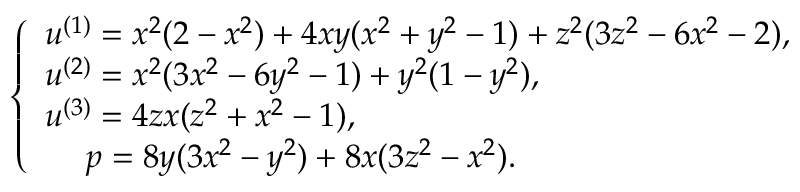Convert formula to latex. <formula><loc_0><loc_0><loc_500><loc_500>\left \{ \begin{array} { l l } { u ^ { ( 1 ) } = x ^ { 2 } ( 2 - x ^ { 2 } ) + 4 x y ( x ^ { 2 } + y ^ { 2 } - 1 ) + z ^ { 2 } ( 3 z ^ { 2 } - 6 x ^ { 2 } - 2 ) , } \\ { u ^ { ( 2 ) } = x ^ { 2 } ( 3 x ^ { 2 } - 6 y ^ { 2 } - 1 ) + y ^ { 2 } ( 1 - y ^ { 2 } ) , } \\ { u ^ { ( 3 ) } = 4 z x ( z ^ { 2 } + x ^ { 2 } - 1 ) , } \\ { \, \quad p = 8 y ( 3 x ^ { 2 } - y ^ { 2 } ) + 8 x ( 3 z ^ { 2 } - x ^ { 2 } ) . } \end{array}</formula> 